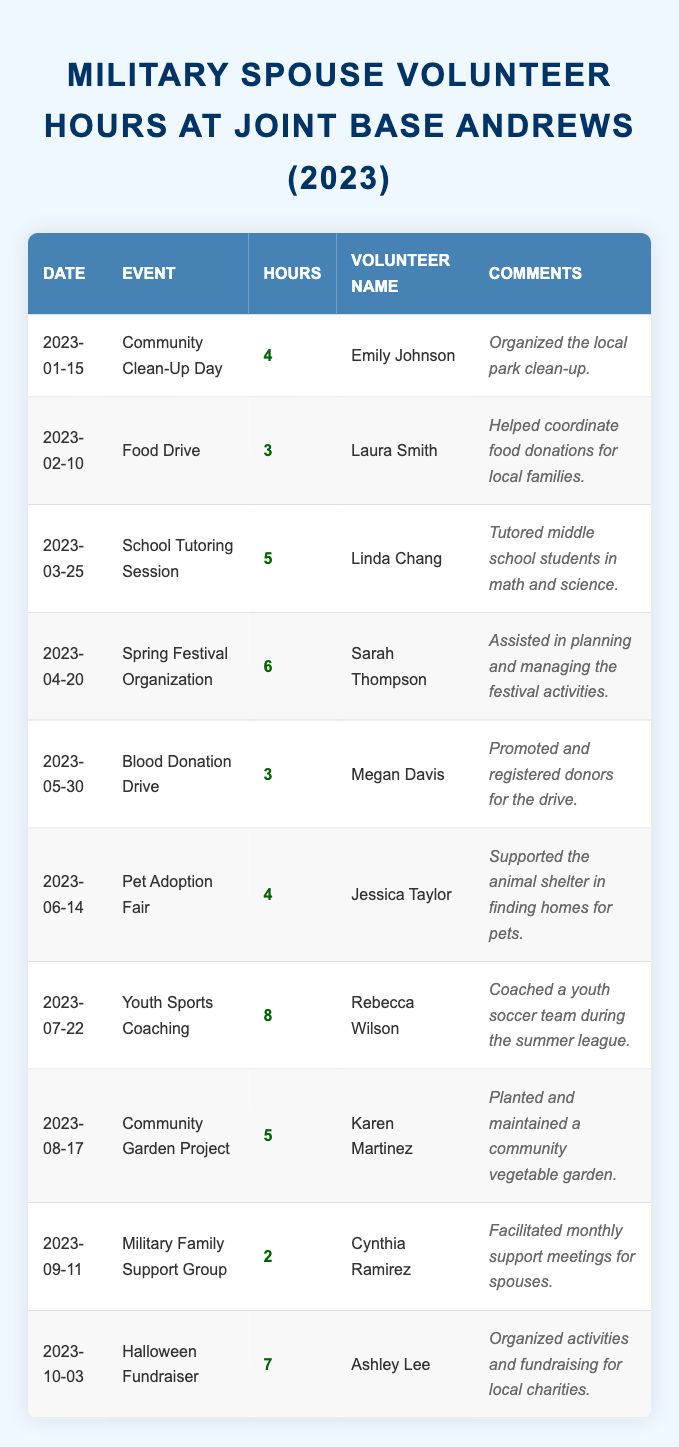What event had the highest volunteer hours? By reviewing the table, we see that "Youth Sports Coaching" had 8 hours, which is the highest among all events listed.
Answer: Youth Sports Coaching Who volunteered the most hours in a single event? Checking the hours column, Rebecca Wilson contributed the most hours (8) for "Youth Sports Coaching."
Answer: Rebecca Wilson How many total volunteer hours were contributed in August? The table shows "Community Garden Project" for August with 5 hours. Therefore, the total for August is 5 hours.
Answer: 5 What was the average number of hours contributed by volunteers for the events listed? Adding up all the hours (4 + 3 + 5 + 6 + 3 + 4 + 8 + 5 + 2 + 7 = 47), there are 10 events, hence the average is 47/10 = 4.7.
Answer: 4.7 Did any volunteers contribute less than 3 hours? Looking at the hours, Cynthia Ramirez contributed 2 hours for the "Military Family Support Group," which is less than 3.
Answer: Yes How many volunteers were involved in events with more than 5 hours of service? The events with more than 5 hours are "Spring Festival Organization" (6 hours) and "Youth Sports Coaching" (8 hours), totaling 2 volunteers.
Answer: 2 What is the total number of volunteer hours for events that took place in the first half of the year (January to June)? The sum of hours from January to June is 4 (Jan) + 3 (Feb) + 5 (Mar) + 6 (Apr) + 3 (May) + 4 (Jun) = 25.
Answer: 25 Which volunteer had the least amount of hours logged, and for what event? Cynthia Ramirez logged 2 hours for "Military Family Support Group," the least amongst the volunteers.
Answer: Cynthia Ramirez, Military Family Support Group Which month had the highest individual volunteer contribution? Looking at the individual hours, July had the highest contribution with 8 hours from Rebecca Wilson for "Youth Sports Coaching."
Answer: July How many different events took place in 2023? From the table, there are 10 unique events listed.
Answer: 10 